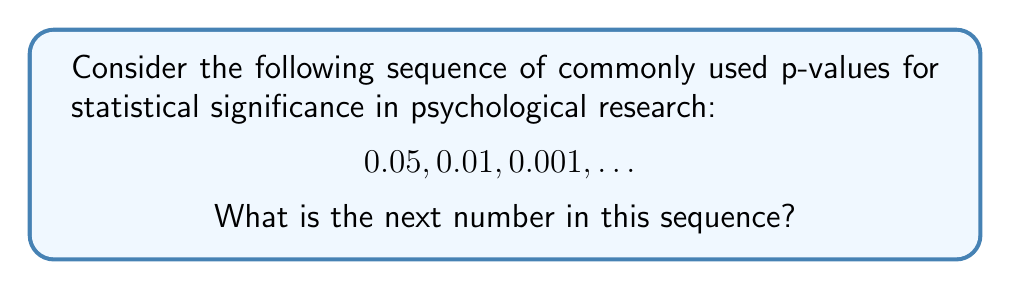Can you answer this question? To solve this problem, let's analyze the pattern in the given sequence:

1) First, we need to recognize that these numbers represent decreasing p-values, which indicate increasing levels of statistical significance.

2) The sequence starts with 0.05, which is the conventional threshold for statistical significance in psychology.

3) Each subsequent number in the sequence represents a more stringent significance level.

4) We can observe that each number is obtained by dividing the previous number by 5:

   $0.05 \div 5 = 0.01$
   $0.01 \div 5 = 0.002$, which is typically rounded to 0.001 in practice

5) Following this pattern, the next number in the sequence would be:

   $0.001 \div 5 = 0.0002$

6) In psychological research, this value is typically expressed in scientific notation as $2 \times 10^{-4}$ or simply reported as "p < 0.0001".

Therefore, the next number in the sequence, maintaining the pattern and conventions in psychological research reporting, would be 0.0001.
Answer: 0.0001 